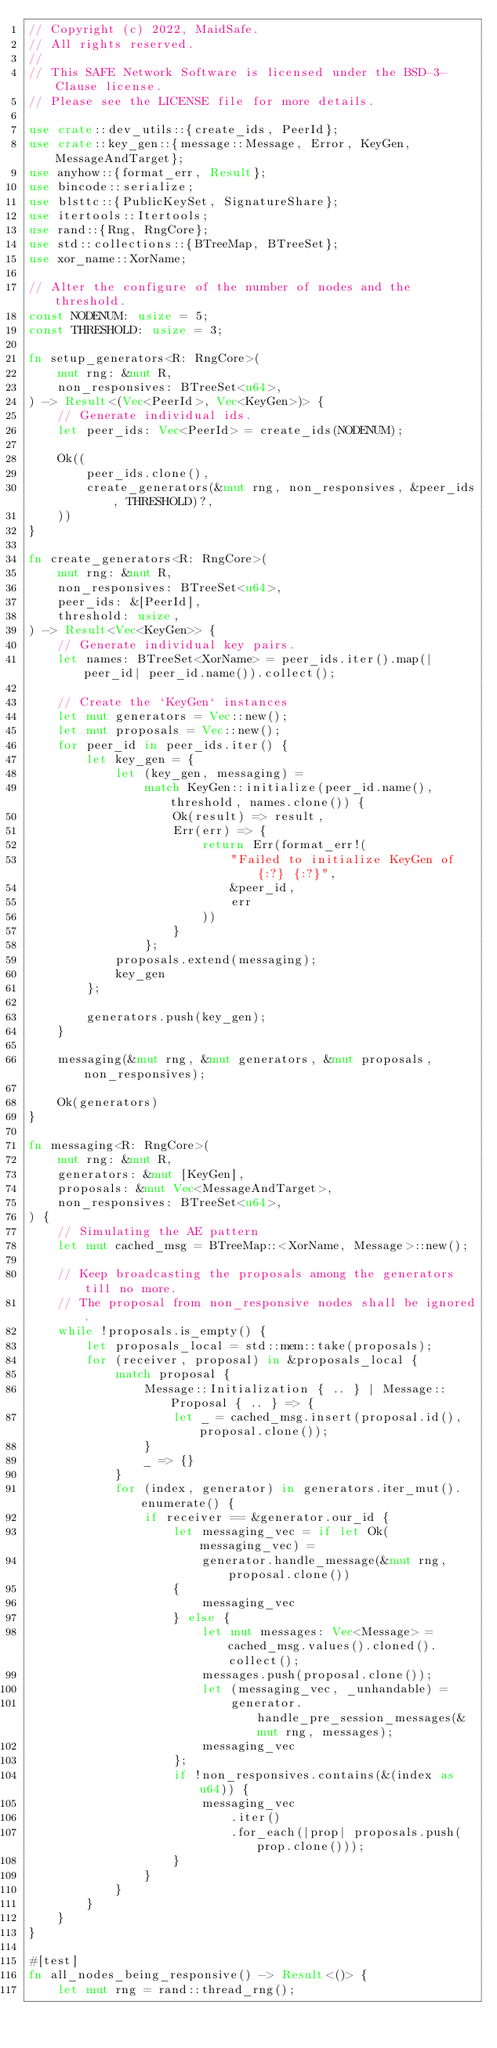<code> <loc_0><loc_0><loc_500><loc_500><_Rust_>// Copyright (c) 2022, MaidSafe.
// All rights reserved.
//
// This SAFE Network Software is licensed under the BSD-3-Clause license.
// Please see the LICENSE file for more details.

use crate::dev_utils::{create_ids, PeerId};
use crate::key_gen::{message::Message, Error, KeyGen, MessageAndTarget};
use anyhow::{format_err, Result};
use bincode::serialize;
use blsttc::{PublicKeySet, SignatureShare};
use itertools::Itertools;
use rand::{Rng, RngCore};
use std::collections::{BTreeMap, BTreeSet};
use xor_name::XorName;

// Alter the configure of the number of nodes and the threshold.
const NODENUM: usize = 5;
const THRESHOLD: usize = 3;

fn setup_generators<R: RngCore>(
    mut rng: &mut R,
    non_responsives: BTreeSet<u64>,
) -> Result<(Vec<PeerId>, Vec<KeyGen>)> {
    // Generate individual ids.
    let peer_ids: Vec<PeerId> = create_ids(NODENUM);

    Ok((
        peer_ids.clone(),
        create_generators(&mut rng, non_responsives, &peer_ids, THRESHOLD)?,
    ))
}

fn create_generators<R: RngCore>(
    mut rng: &mut R,
    non_responsives: BTreeSet<u64>,
    peer_ids: &[PeerId],
    threshold: usize,
) -> Result<Vec<KeyGen>> {
    // Generate individual key pairs.
    let names: BTreeSet<XorName> = peer_ids.iter().map(|peer_id| peer_id.name()).collect();

    // Create the `KeyGen` instances
    let mut generators = Vec::new();
    let mut proposals = Vec::new();
    for peer_id in peer_ids.iter() {
        let key_gen = {
            let (key_gen, messaging) =
                match KeyGen::initialize(peer_id.name(), threshold, names.clone()) {
                    Ok(result) => result,
                    Err(err) => {
                        return Err(format_err!(
                            "Failed to initialize KeyGen of {:?} {:?}",
                            &peer_id,
                            err
                        ))
                    }
                };
            proposals.extend(messaging);
            key_gen
        };

        generators.push(key_gen);
    }

    messaging(&mut rng, &mut generators, &mut proposals, non_responsives);

    Ok(generators)
}

fn messaging<R: RngCore>(
    mut rng: &mut R,
    generators: &mut [KeyGen],
    proposals: &mut Vec<MessageAndTarget>,
    non_responsives: BTreeSet<u64>,
) {
    // Simulating the AE pattern
    let mut cached_msg = BTreeMap::<XorName, Message>::new();

    // Keep broadcasting the proposals among the generators till no more.
    // The proposal from non_responsive nodes shall be ignored.
    while !proposals.is_empty() {
        let proposals_local = std::mem::take(proposals);
        for (receiver, proposal) in &proposals_local {
            match proposal {
                Message::Initialization { .. } | Message::Proposal { .. } => {
                    let _ = cached_msg.insert(proposal.id(), proposal.clone());
                }
                _ => {}
            }
            for (index, generator) in generators.iter_mut().enumerate() {
                if receiver == &generator.our_id {
                    let messaging_vec = if let Ok(messaging_vec) =
                        generator.handle_message(&mut rng, proposal.clone())
                    {
                        messaging_vec
                    } else {
                        let mut messages: Vec<Message> = cached_msg.values().cloned().collect();
                        messages.push(proposal.clone());
                        let (messaging_vec, _unhandable) =
                            generator.handle_pre_session_messages(&mut rng, messages);
                        messaging_vec
                    };
                    if !non_responsives.contains(&(index as u64)) {
                        messaging_vec
                            .iter()
                            .for_each(|prop| proposals.push(prop.clone()));
                    }
                }
            }
        }
    }
}

#[test]
fn all_nodes_being_responsive() -> Result<()> {
    let mut rng = rand::thread_rng();</code> 